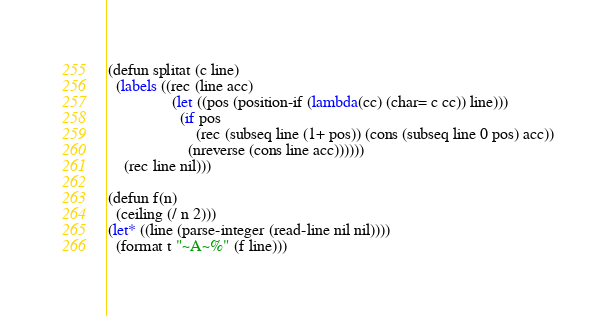<code> <loc_0><loc_0><loc_500><loc_500><_Lisp_>(defun splitat (c line)
  (labels ((rec (line acc)
				(let ((pos (position-if (lambda(cc) (char= c cc)) line)))
				  (if pos
					  (rec (subseq line (1+ pos)) (cons (subseq line 0 pos) acc))
					(nreverse (cons line acc))))))
	(rec line nil)))

(defun f(n)
  (ceiling (/ n 2)))
(let* ((line (parse-integer (read-line nil nil))))
  (format t "~A~%" (f line)))
</code> 